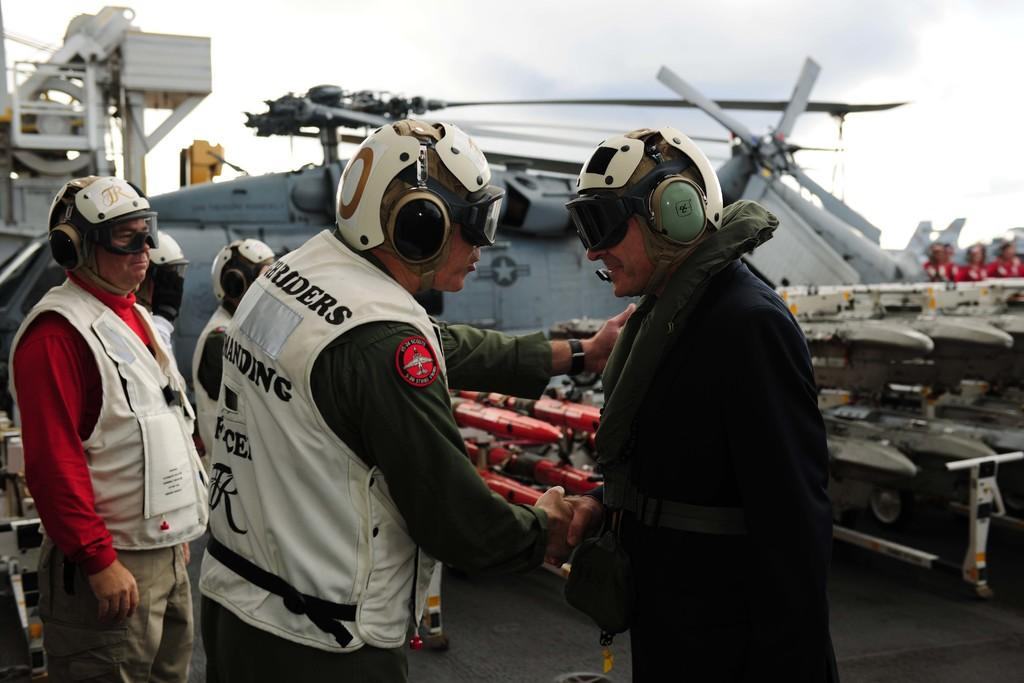What are the people in the image doing? The people in the image are standing on the ground. What else can be seen in the image besides the people? Aircrafts are visible in the image. What is visible in the background of the image? The sky is visible in the background of the image. How many clocks are hanging from the pockets of the people in the image? There are no clocks visible in the image, and the people in the image are not shown wearing pockets. 